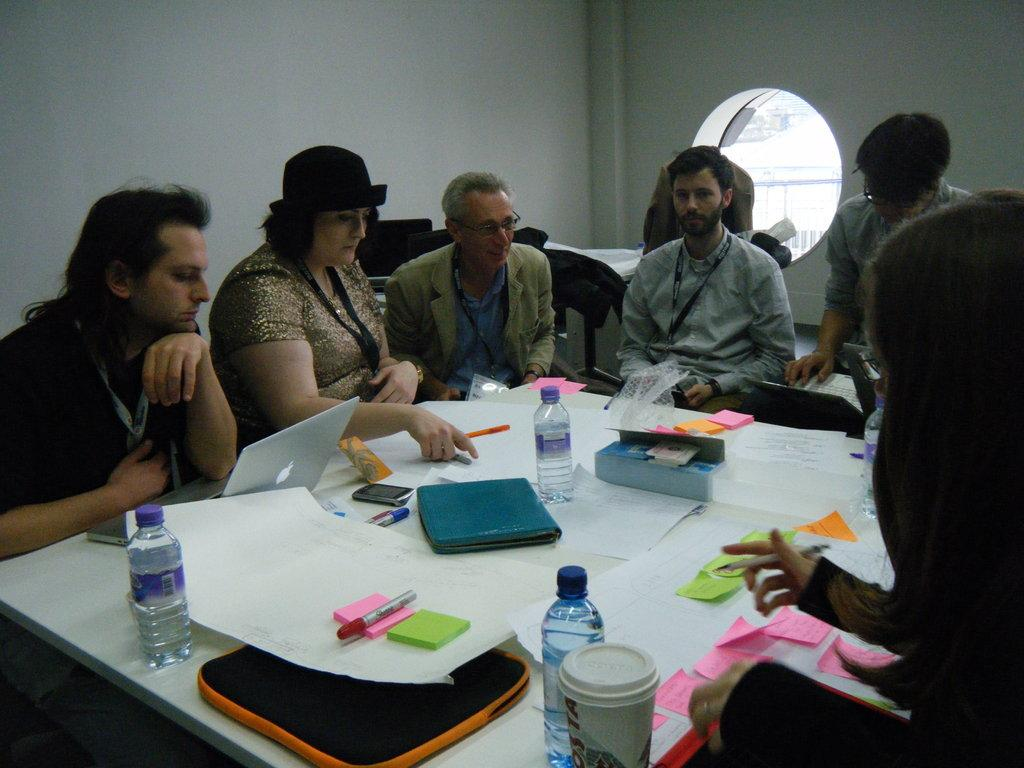What type of furniture is in the image? There is a table in the image. What items can be seen on the table? Bottles, a paper, a pen, and books are present on the table. What is the person in the image doing? The presence of a pen and paper suggests that the person might be writing or taking notes. What is visible at the top of the image? The wall is visible at the top of the image. How many cakes are displayed in the shop in the image? There is no shop or cakes present in the image; it features a table with various items and a person. 